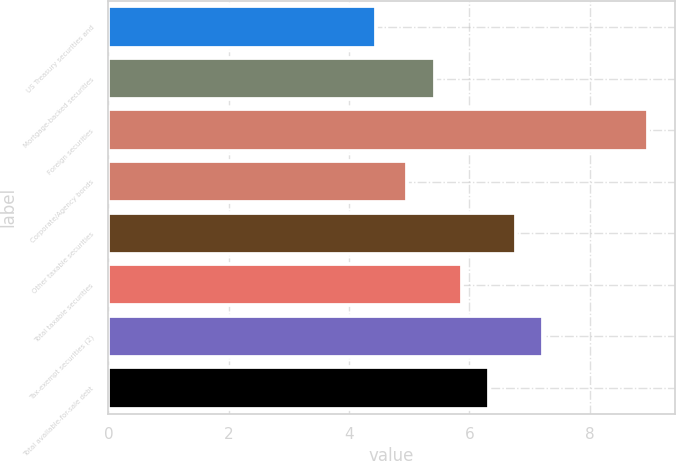Convert chart to OTSL. <chart><loc_0><loc_0><loc_500><loc_500><bar_chart><fcel>US Treasury securities and<fcel>Mortgage-backed securities<fcel>Foreign securities<fcel>Corporate/Agency bonds<fcel>Other taxable securities<fcel>Total taxable securities<fcel>Tax-exempt securities (2)<fcel>Total available-for-sale debt<nl><fcel>4.45<fcel>5.42<fcel>8.96<fcel>4.97<fcel>6.77<fcel>5.87<fcel>7.22<fcel>6.32<nl></chart> 